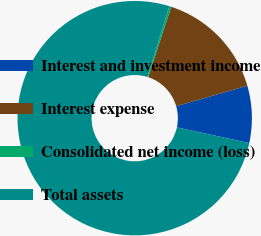Convert chart to OTSL. <chart><loc_0><loc_0><loc_500><loc_500><pie_chart><fcel>Interest and investment income<fcel>Interest expense<fcel>Consolidated net income (loss)<fcel>Total assets<nl><fcel>7.88%<fcel>15.49%<fcel>0.27%<fcel>76.37%<nl></chart> 